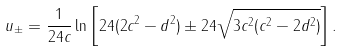Convert formula to latex. <formula><loc_0><loc_0><loc_500><loc_500>u _ { \pm } = \frac { 1 } { 2 4 c } \ln \left [ 2 4 ( 2 c ^ { 2 } - d ^ { 2 } ) \pm 2 4 \sqrt { 3 c ^ { 2 } ( c ^ { 2 } - 2 d ^ { 2 } ) } \right ] .</formula> 